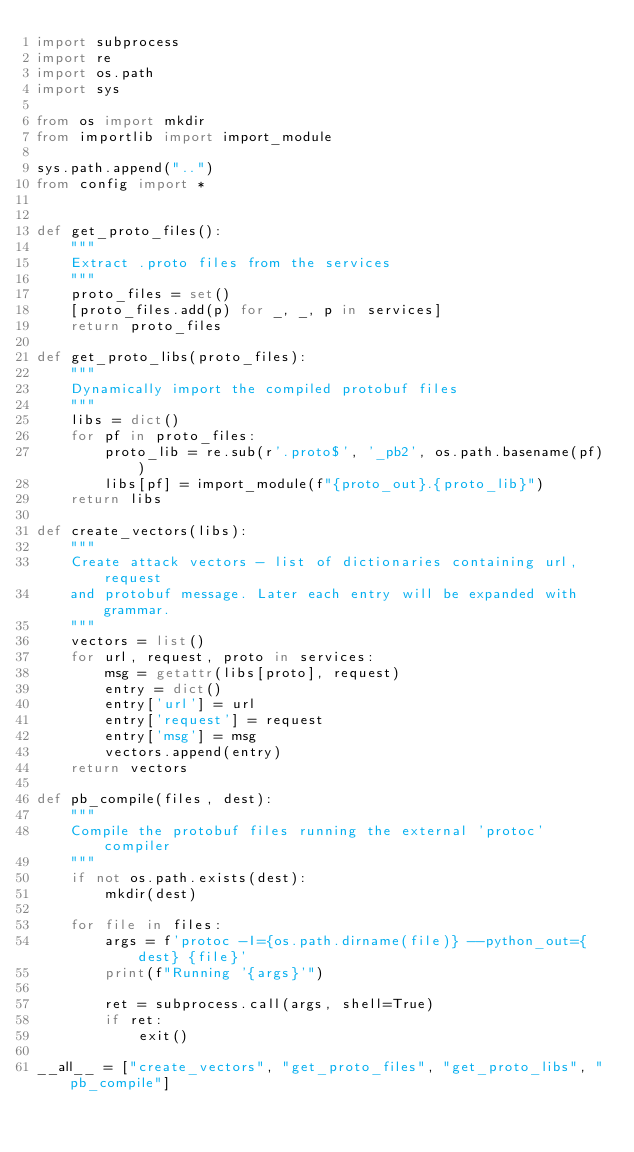<code> <loc_0><loc_0><loc_500><loc_500><_Python_>import subprocess
import re
import os.path
import sys

from os import mkdir
from importlib import import_module

sys.path.append("..")
from config import *


def get_proto_files():
    """
    Extract .proto files from the services
    """
    proto_files = set()
    [proto_files.add(p) for _, _, p in services]
    return proto_files

def get_proto_libs(proto_files):
    """
    Dynamically import the compiled protobuf files
    """
    libs = dict()
    for pf in proto_files:
        proto_lib = re.sub(r'.proto$', '_pb2', os.path.basename(pf))
        libs[pf] = import_module(f"{proto_out}.{proto_lib}")
    return libs

def create_vectors(libs):
    """
    Create attack vectors - list of dictionaries containing url, request 
    and protobuf message. Later each entry will be expanded with grammar.
    """
    vectors = list()
    for url, request, proto in services:
        msg = getattr(libs[proto], request)
        entry = dict()
        entry['url'] = url
        entry['request'] = request
        entry['msg'] = msg 
        vectors.append(entry)
    return vectors
    
def pb_compile(files, dest):
    """
    Compile the protobuf files running the external 'protoc' compiler
    """
    if not os.path.exists(dest):
        mkdir(dest)

    for file in files:
        args = f'protoc -I={os.path.dirname(file)} --python_out={dest} {file}'
        print(f"Running '{args}'")

        ret = subprocess.call(args, shell=True)
        if ret:
            exit()

__all__ = ["create_vectors", "get_proto_files", "get_proto_libs", "pb_compile"]
</code> 